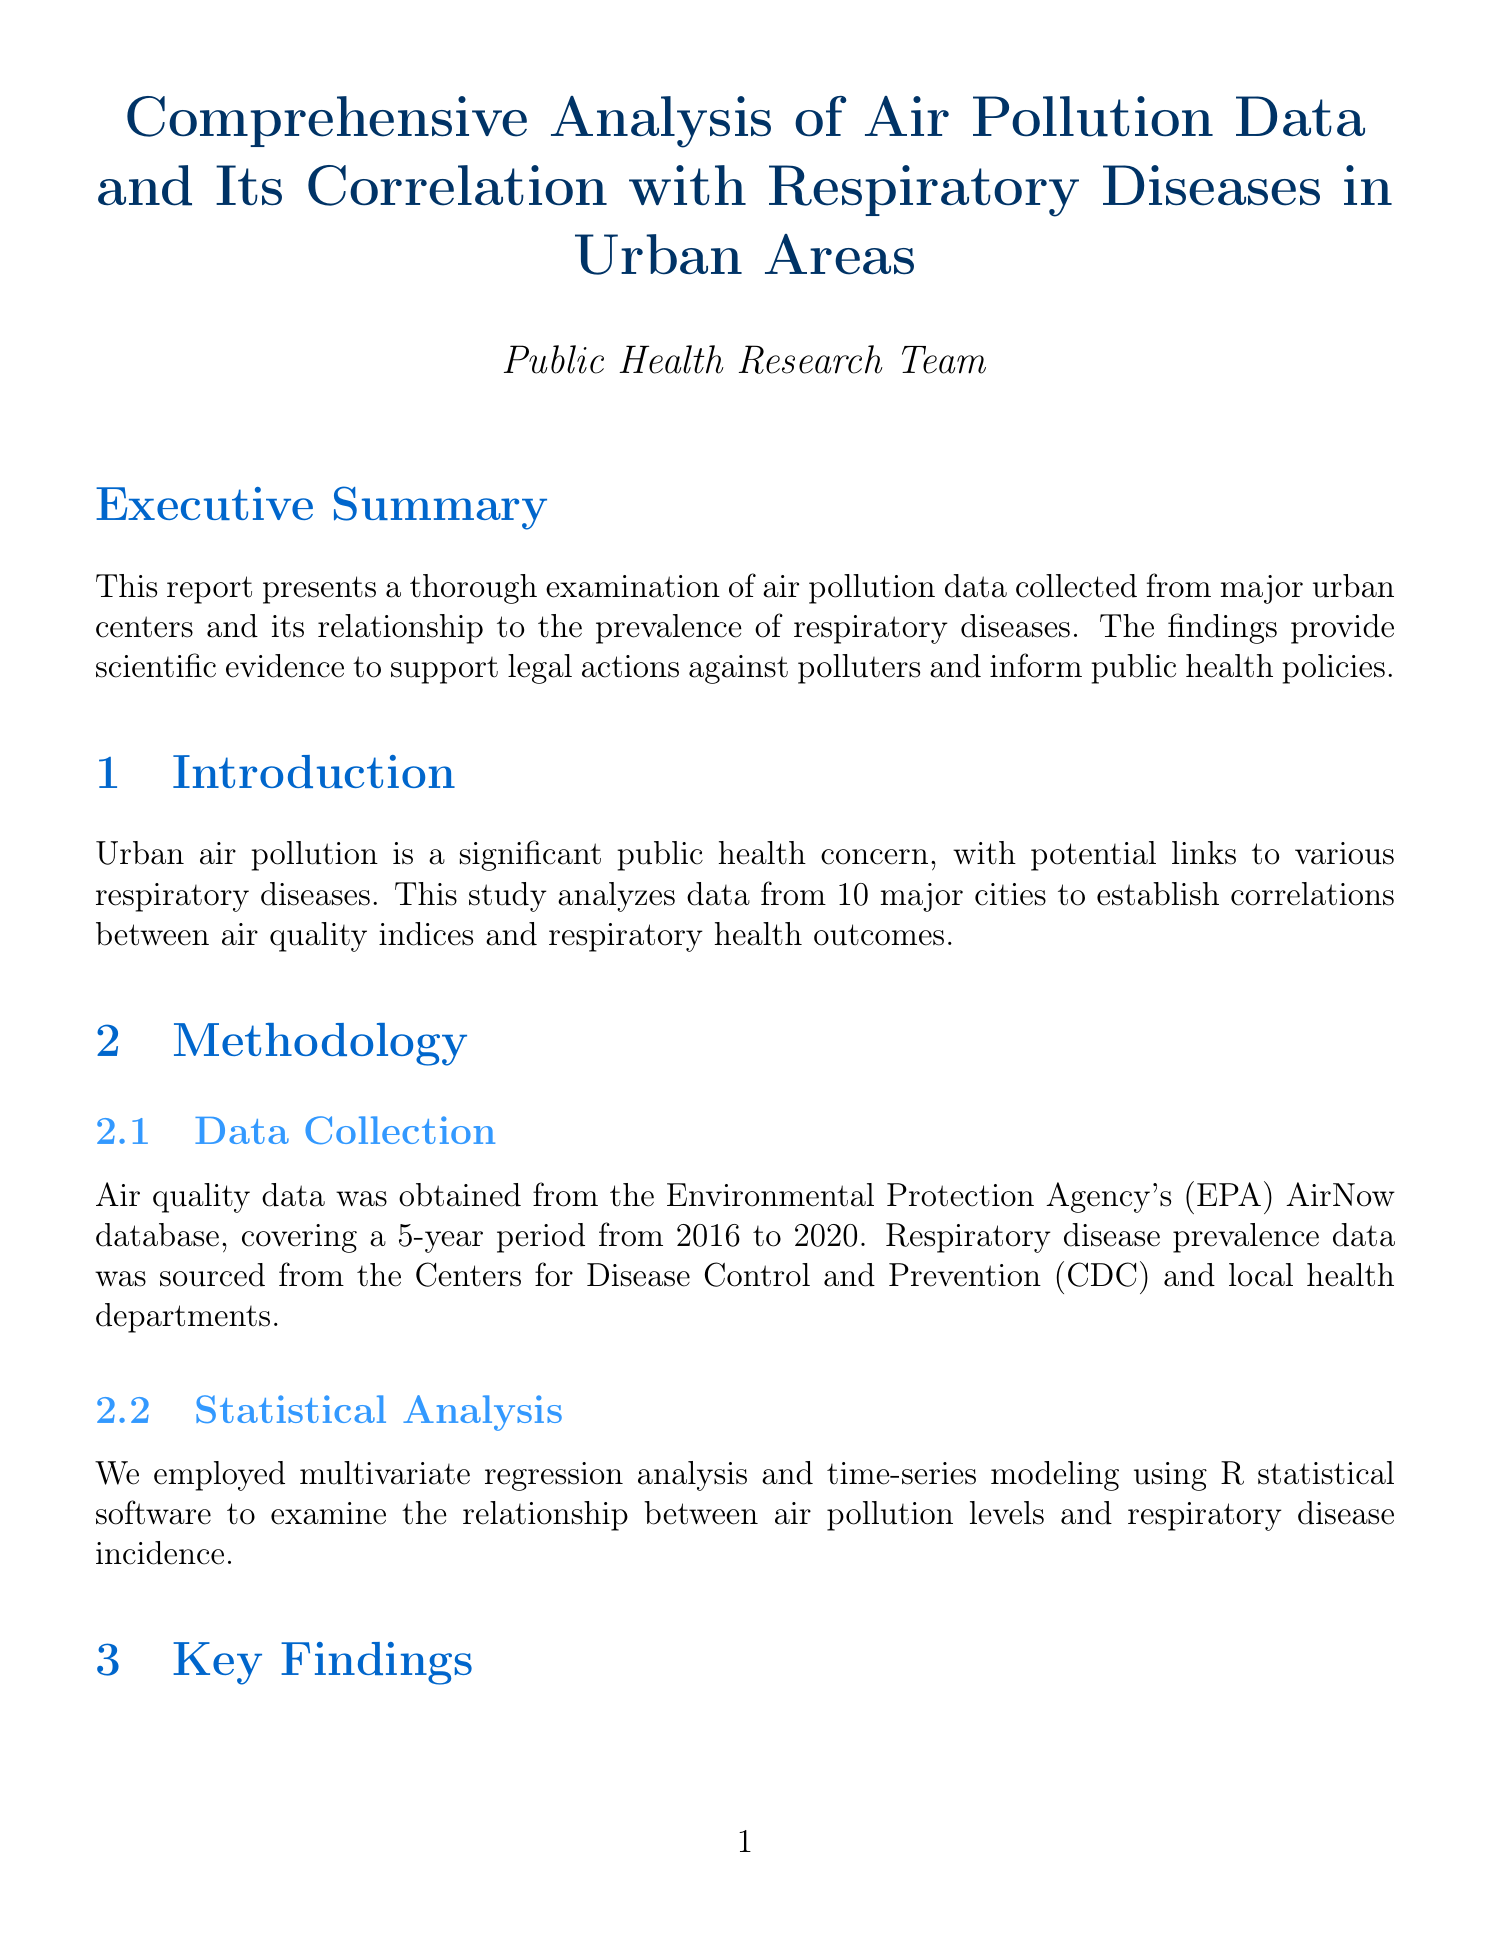What is the title of the report? The title is presented at the beginning of the document.
Answer: Comprehensive Analysis of Air Pollution Data and Its Correlation with Respiratory Diseases in Urban Areas What years does the data collection cover? The report specifies the data collection period in the Methodology section.
Answer: 2016 to 2020 What statistical software was used for analysis? The Methodology section notes the software used for statistical analysis.
Answer: R What correlation coefficient was found between PM2.5 levels and asthma hospitalization rates? The Key Findings section provides the correlation coefficient for PM2.5 and asthma.
Answer: 0.78 What percentage increase in COPD exacerbations is associated with elevated ozone levels? The report details this percentage in the Key Findings section.
Answer: 22% Which city is mentioned in the case study concerning high ozone levels? The Case Studies section provides specific cities studied.
Answer: Los Angeles What measure was implemented in Beijing in 2008 that affected respiratory-related hospital admissions? The Case Studies section describes this intervention.
Answer: Strict air pollution control measures What does the report recommend for vulnerable communities? Recommendations are given towards the end of the document.
Answer: Implementation of urban planning strategies What is the main legal implication discussed in the report? The Legal Implications section addresses the primary legal aspect derived from the findings.
Answer: Violation of the Clean Air Act 